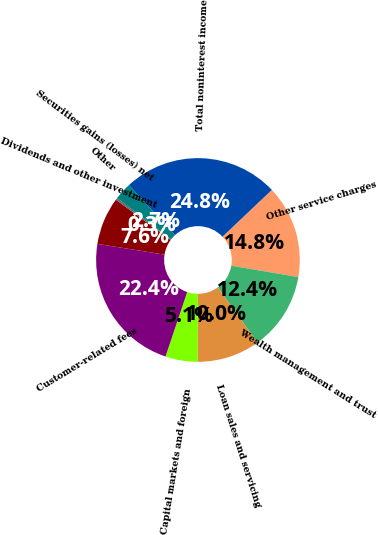Convert chart. <chart><loc_0><loc_0><loc_500><loc_500><pie_chart><fcel>Other service charges<fcel>Wealth management and trust<fcel>Loan sales and servicing<fcel>Capital markets and foreign<fcel>Customer-related fees<fcel>Dividends and other investment<fcel>Securities gains (losses) net<fcel>Other<fcel>Total noninterest income<nl><fcel>14.77%<fcel>12.37%<fcel>9.96%<fcel>5.14%<fcel>22.37%<fcel>7.55%<fcel>0.33%<fcel>2.74%<fcel>24.77%<nl></chart> 